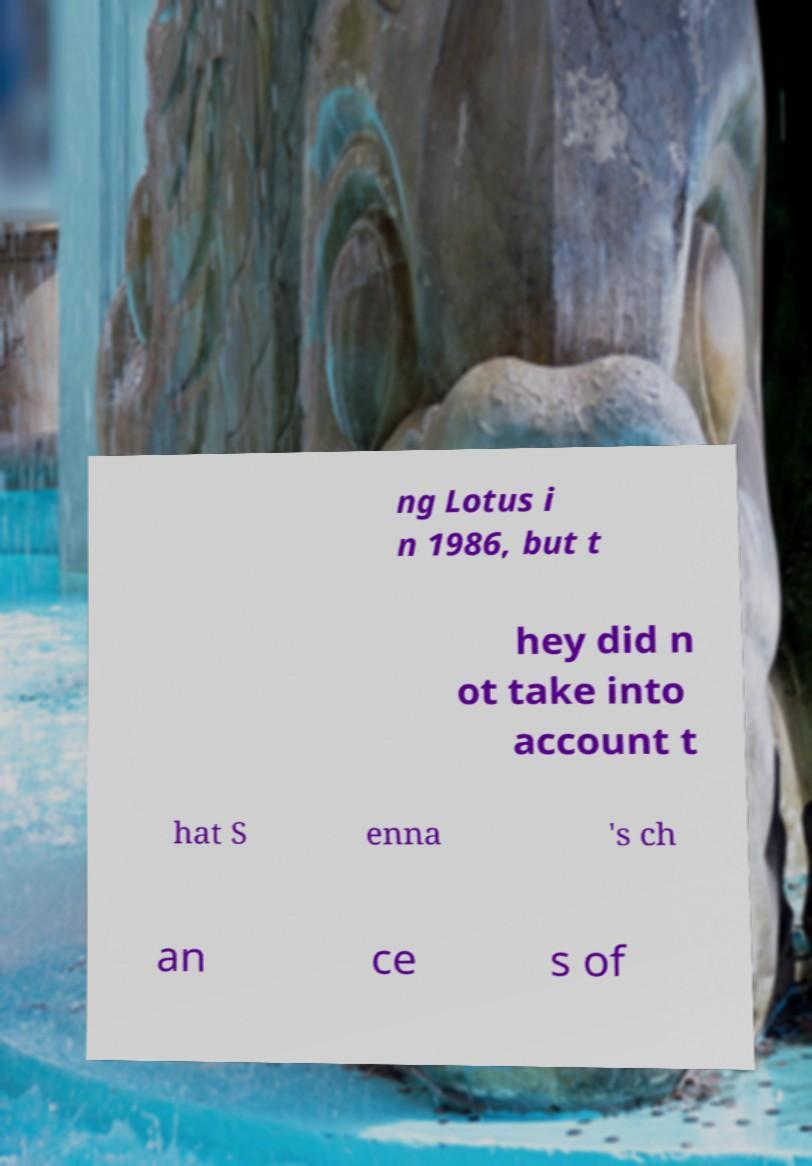Could you assist in decoding the text presented in this image and type it out clearly? ng Lotus i n 1986, but t hey did n ot take into account t hat S enna 's ch an ce s of 